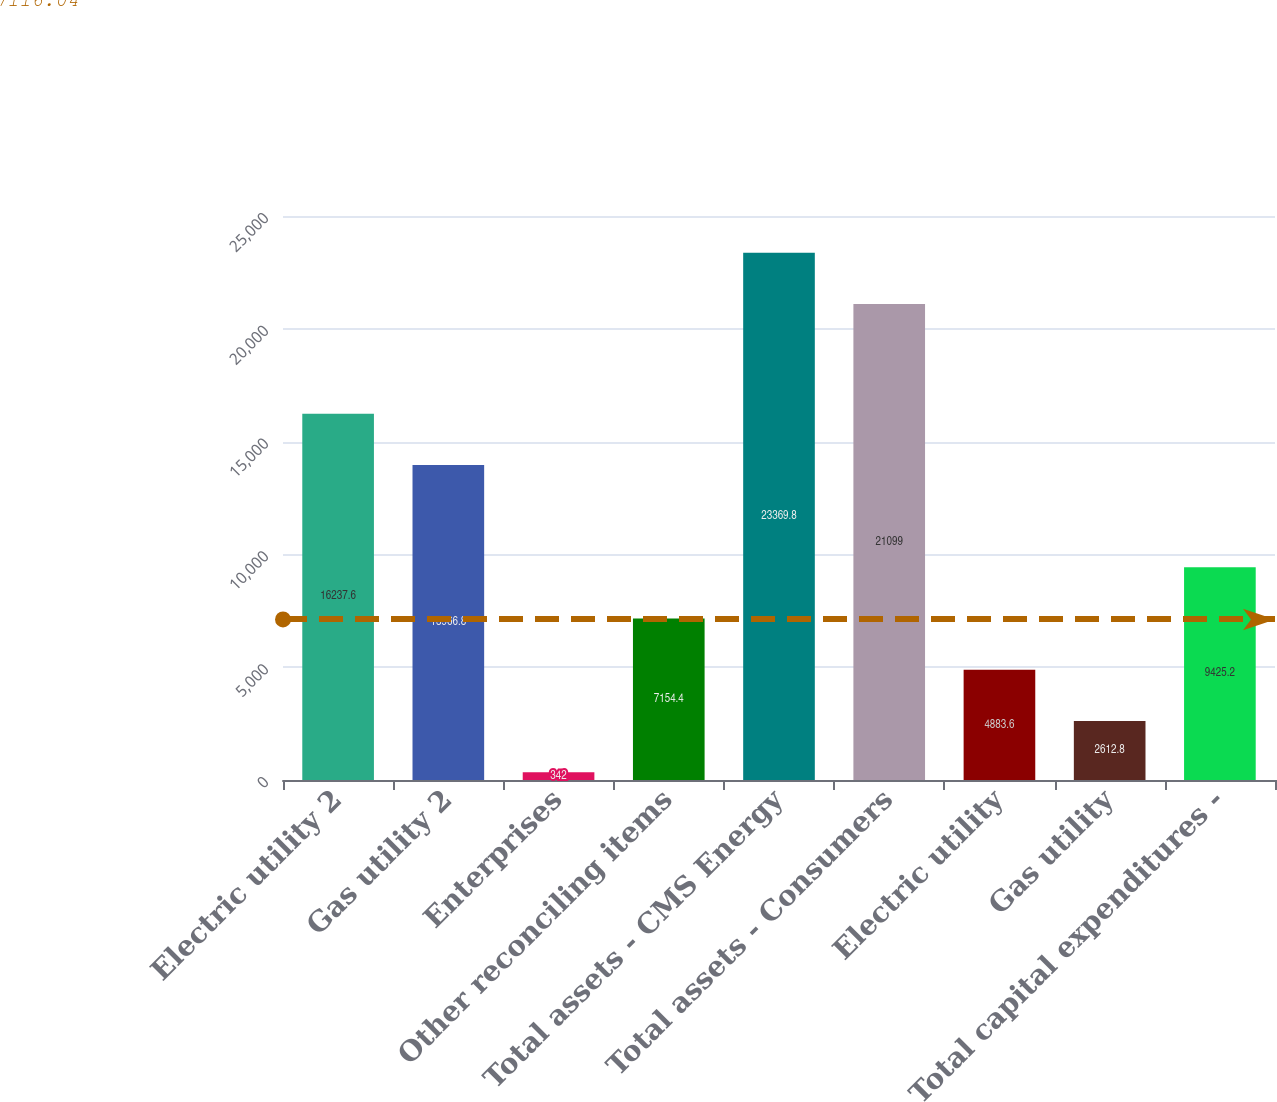Convert chart to OTSL. <chart><loc_0><loc_0><loc_500><loc_500><bar_chart><fcel>Electric utility 2<fcel>Gas utility 2<fcel>Enterprises<fcel>Other reconciling items<fcel>Total assets - CMS Energy<fcel>Total assets - Consumers<fcel>Electric utility<fcel>Gas utility<fcel>Total capital expenditures -<nl><fcel>16237.6<fcel>13966.8<fcel>342<fcel>7154.4<fcel>23369.8<fcel>21099<fcel>4883.6<fcel>2612.8<fcel>9425.2<nl></chart> 